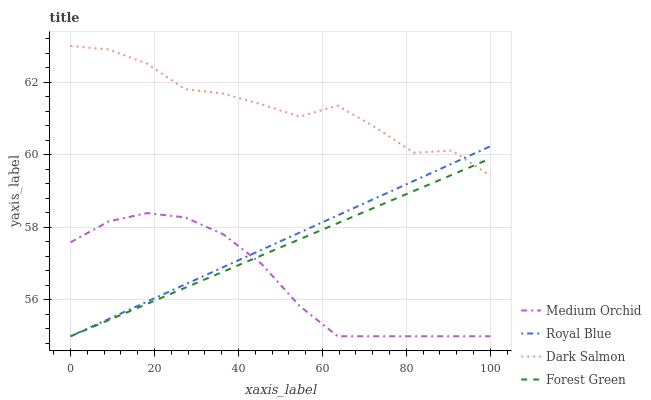Does Medium Orchid have the minimum area under the curve?
Answer yes or no. Yes. Does Dark Salmon have the maximum area under the curve?
Answer yes or no. Yes. Does Forest Green have the minimum area under the curve?
Answer yes or no. No. Does Forest Green have the maximum area under the curve?
Answer yes or no. No. Is Royal Blue the smoothest?
Answer yes or no. Yes. Is Dark Salmon the roughest?
Answer yes or no. Yes. Is Forest Green the smoothest?
Answer yes or no. No. Is Forest Green the roughest?
Answer yes or no. No. Does Dark Salmon have the lowest value?
Answer yes or no. No. Does Forest Green have the highest value?
Answer yes or no. No. Is Medium Orchid less than Dark Salmon?
Answer yes or no. Yes. Is Dark Salmon greater than Medium Orchid?
Answer yes or no. Yes. Does Medium Orchid intersect Dark Salmon?
Answer yes or no. No. 